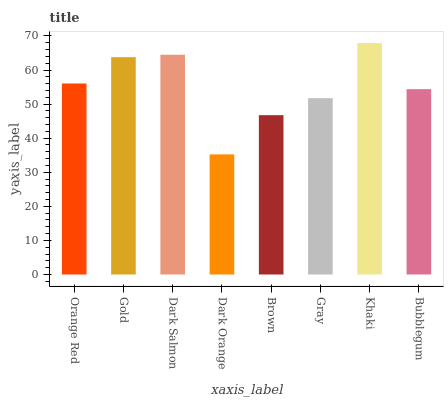Is Dark Orange the minimum?
Answer yes or no. Yes. Is Khaki the maximum?
Answer yes or no. Yes. Is Gold the minimum?
Answer yes or no. No. Is Gold the maximum?
Answer yes or no. No. Is Gold greater than Orange Red?
Answer yes or no. Yes. Is Orange Red less than Gold?
Answer yes or no. Yes. Is Orange Red greater than Gold?
Answer yes or no. No. Is Gold less than Orange Red?
Answer yes or no. No. Is Orange Red the high median?
Answer yes or no. Yes. Is Bubblegum the low median?
Answer yes or no. Yes. Is Gray the high median?
Answer yes or no. No. Is Gold the low median?
Answer yes or no. No. 